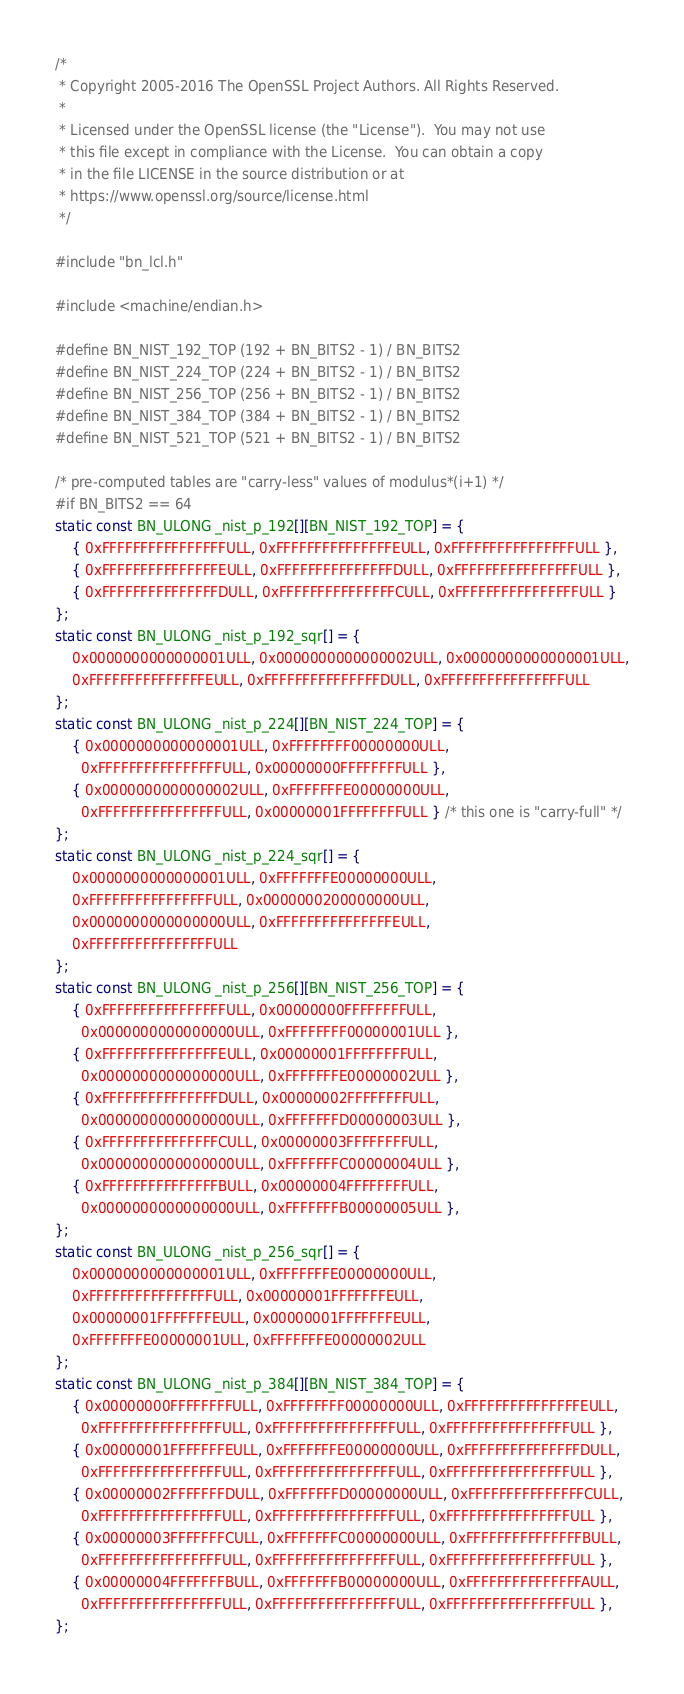<code> <loc_0><loc_0><loc_500><loc_500><_C_>/*
 * Copyright 2005-2016 The OpenSSL Project Authors. All Rights Reserved.
 *
 * Licensed under the OpenSSL license (the "License").  You may not use
 * this file except in compliance with the License.  You can obtain a copy
 * in the file LICENSE in the source distribution or at
 * https://www.openssl.org/source/license.html
 */

#include "bn_lcl.h"

#include <machine/endian.h>

#define BN_NIST_192_TOP (192 + BN_BITS2 - 1) / BN_BITS2
#define BN_NIST_224_TOP (224 + BN_BITS2 - 1) / BN_BITS2
#define BN_NIST_256_TOP (256 + BN_BITS2 - 1) / BN_BITS2
#define BN_NIST_384_TOP (384 + BN_BITS2 - 1) / BN_BITS2
#define BN_NIST_521_TOP (521 + BN_BITS2 - 1) / BN_BITS2

/* pre-computed tables are "carry-less" values of modulus*(i+1) */
#if BN_BITS2 == 64
static const BN_ULONG _nist_p_192[][BN_NIST_192_TOP] = {
    { 0xFFFFFFFFFFFFFFFFULL, 0xFFFFFFFFFFFFFFFEULL, 0xFFFFFFFFFFFFFFFFULL },
    { 0xFFFFFFFFFFFFFFFEULL, 0xFFFFFFFFFFFFFFFDULL, 0xFFFFFFFFFFFFFFFFULL },
    { 0xFFFFFFFFFFFFFFFDULL, 0xFFFFFFFFFFFFFFFCULL, 0xFFFFFFFFFFFFFFFFULL }
};
static const BN_ULONG _nist_p_192_sqr[] = {
    0x0000000000000001ULL, 0x0000000000000002ULL, 0x0000000000000001ULL,
    0xFFFFFFFFFFFFFFFEULL, 0xFFFFFFFFFFFFFFFDULL, 0xFFFFFFFFFFFFFFFFULL
};
static const BN_ULONG _nist_p_224[][BN_NIST_224_TOP] = {
    { 0x0000000000000001ULL, 0xFFFFFFFF00000000ULL,
      0xFFFFFFFFFFFFFFFFULL, 0x00000000FFFFFFFFULL },
    { 0x0000000000000002ULL, 0xFFFFFFFE00000000ULL,
      0xFFFFFFFFFFFFFFFFULL, 0x00000001FFFFFFFFULL } /* this one is "carry-full" */
};
static const BN_ULONG _nist_p_224_sqr[] = {
    0x0000000000000001ULL, 0xFFFFFFFE00000000ULL,
    0xFFFFFFFFFFFFFFFFULL, 0x0000000200000000ULL,
    0x0000000000000000ULL, 0xFFFFFFFFFFFFFFFEULL,
    0xFFFFFFFFFFFFFFFFULL
};
static const BN_ULONG _nist_p_256[][BN_NIST_256_TOP] = {
    { 0xFFFFFFFFFFFFFFFFULL, 0x00000000FFFFFFFFULL,
      0x0000000000000000ULL, 0xFFFFFFFF00000001ULL },
    { 0xFFFFFFFFFFFFFFFEULL, 0x00000001FFFFFFFFULL,
      0x0000000000000000ULL, 0xFFFFFFFE00000002ULL },
    { 0xFFFFFFFFFFFFFFFDULL, 0x00000002FFFFFFFFULL,
      0x0000000000000000ULL, 0xFFFFFFFD00000003ULL },
    { 0xFFFFFFFFFFFFFFFCULL, 0x00000003FFFFFFFFULL,
      0x0000000000000000ULL, 0xFFFFFFFC00000004ULL },
    { 0xFFFFFFFFFFFFFFFBULL, 0x00000004FFFFFFFFULL,
      0x0000000000000000ULL, 0xFFFFFFFB00000005ULL },
};
static const BN_ULONG _nist_p_256_sqr[] = {
    0x0000000000000001ULL, 0xFFFFFFFE00000000ULL,
    0xFFFFFFFFFFFFFFFFULL, 0x00000001FFFFFFFEULL,
    0x00000001FFFFFFFEULL, 0x00000001FFFFFFFEULL,
    0xFFFFFFFE00000001ULL, 0xFFFFFFFE00000002ULL
};
static const BN_ULONG _nist_p_384[][BN_NIST_384_TOP] = {
    { 0x00000000FFFFFFFFULL, 0xFFFFFFFF00000000ULL, 0xFFFFFFFFFFFFFFFEULL,
      0xFFFFFFFFFFFFFFFFULL, 0xFFFFFFFFFFFFFFFFULL, 0xFFFFFFFFFFFFFFFFULL },
    { 0x00000001FFFFFFFEULL, 0xFFFFFFFE00000000ULL, 0xFFFFFFFFFFFFFFFDULL,
      0xFFFFFFFFFFFFFFFFULL, 0xFFFFFFFFFFFFFFFFULL, 0xFFFFFFFFFFFFFFFFULL },
    { 0x00000002FFFFFFFDULL, 0xFFFFFFFD00000000ULL, 0xFFFFFFFFFFFFFFFCULL,
      0xFFFFFFFFFFFFFFFFULL, 0xFFFFFFFFFFFFFFFFULL, 0xFFFFFFFFFFFFFFFFULL },
    { 0x00000003FFFFFFFCULL, 0xFFFFFFFC00000000ULL, 0xFFFFFFFFFFFFFFFBULL,
      0xFFFFFFFFFFFFFFFFULL, 0xFFFFFFFFFFFFFFFFULL, 0xFFFFFFFFFFFFFFFFULL },
    { 0x00000004FFFFFFFBULL, 0xFFFFFFFB00000000ULL, 0xFFFFFFFFFFFFFFFAULL,
      0xFFFFFFFFFFFFFFFFULL, 0xFFFFFFFFFFFFFFFFULL, 0xFFFFFFFFFFFFFFFFULL },
};</code> 